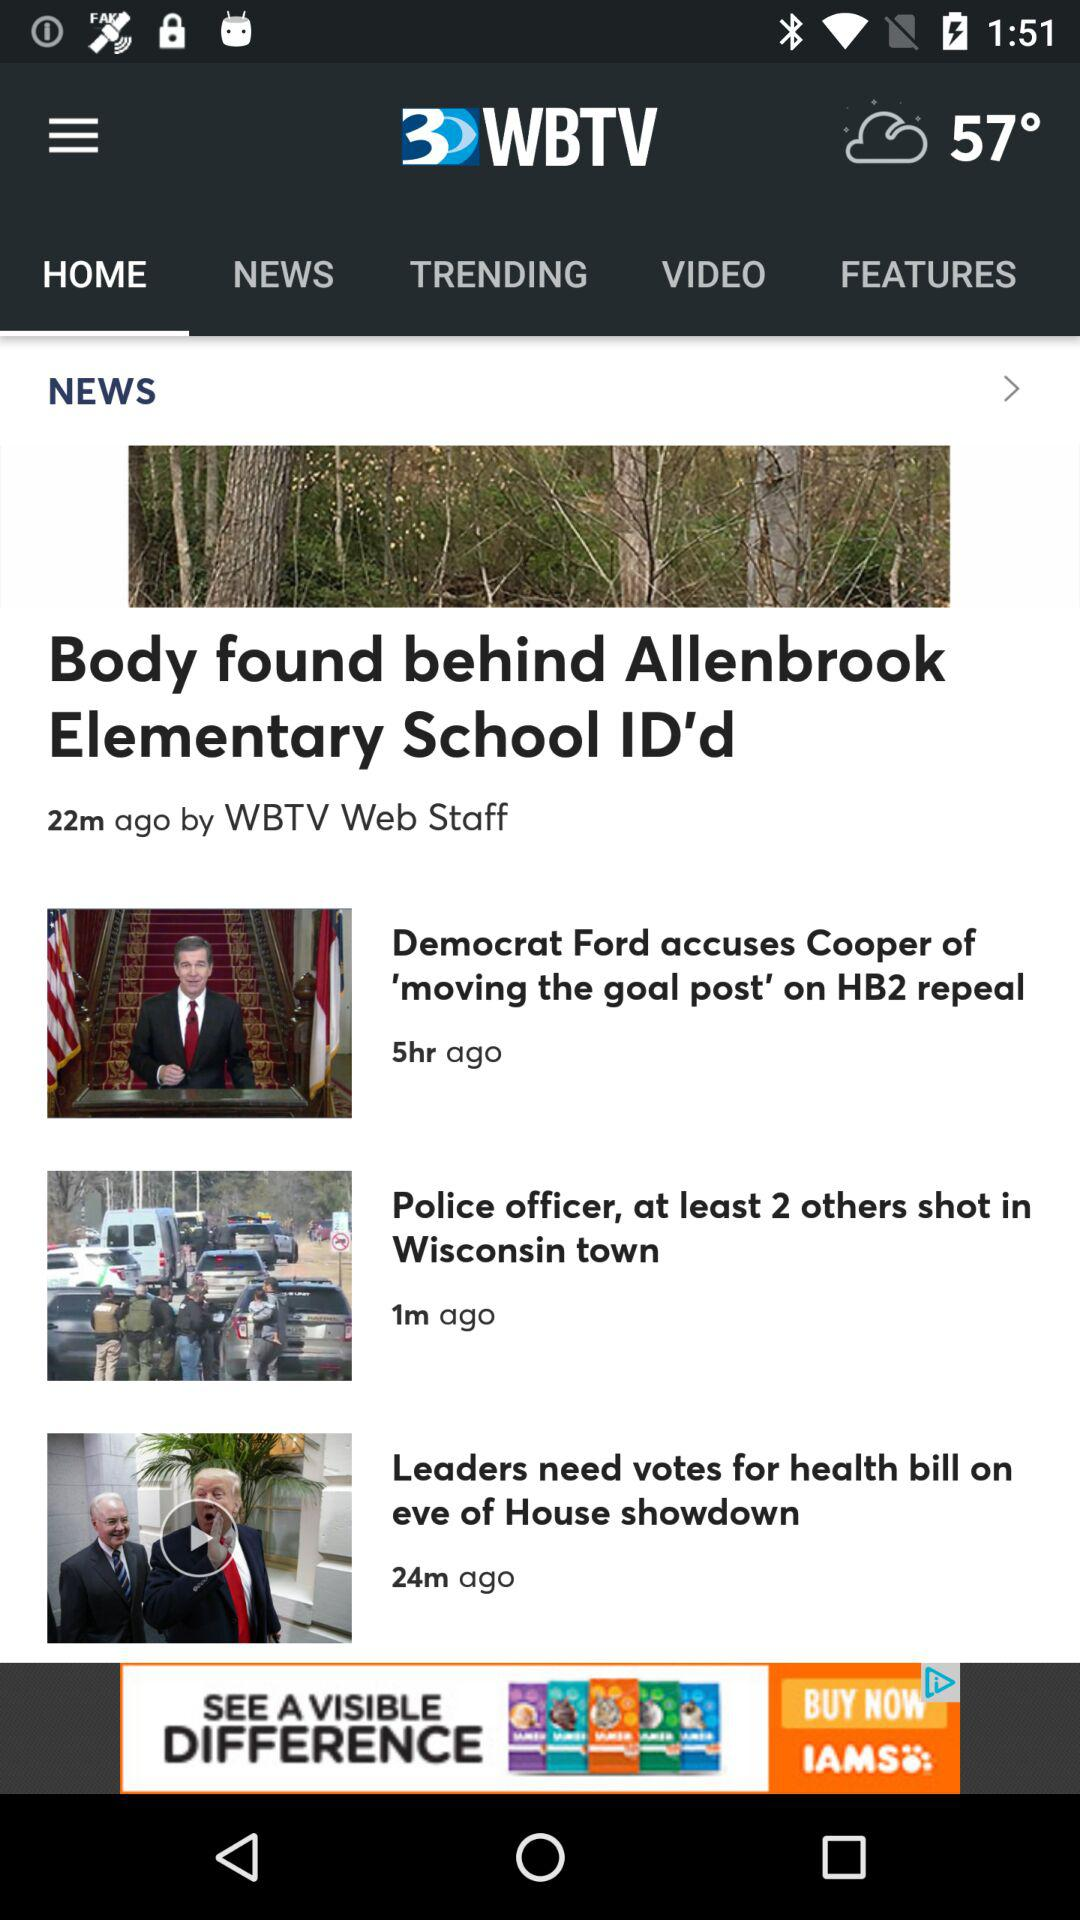What is the title of the article published by the WBTV Web Staff? The title of the article is "Body found behind Allenbrook Elementary School ID'd". 